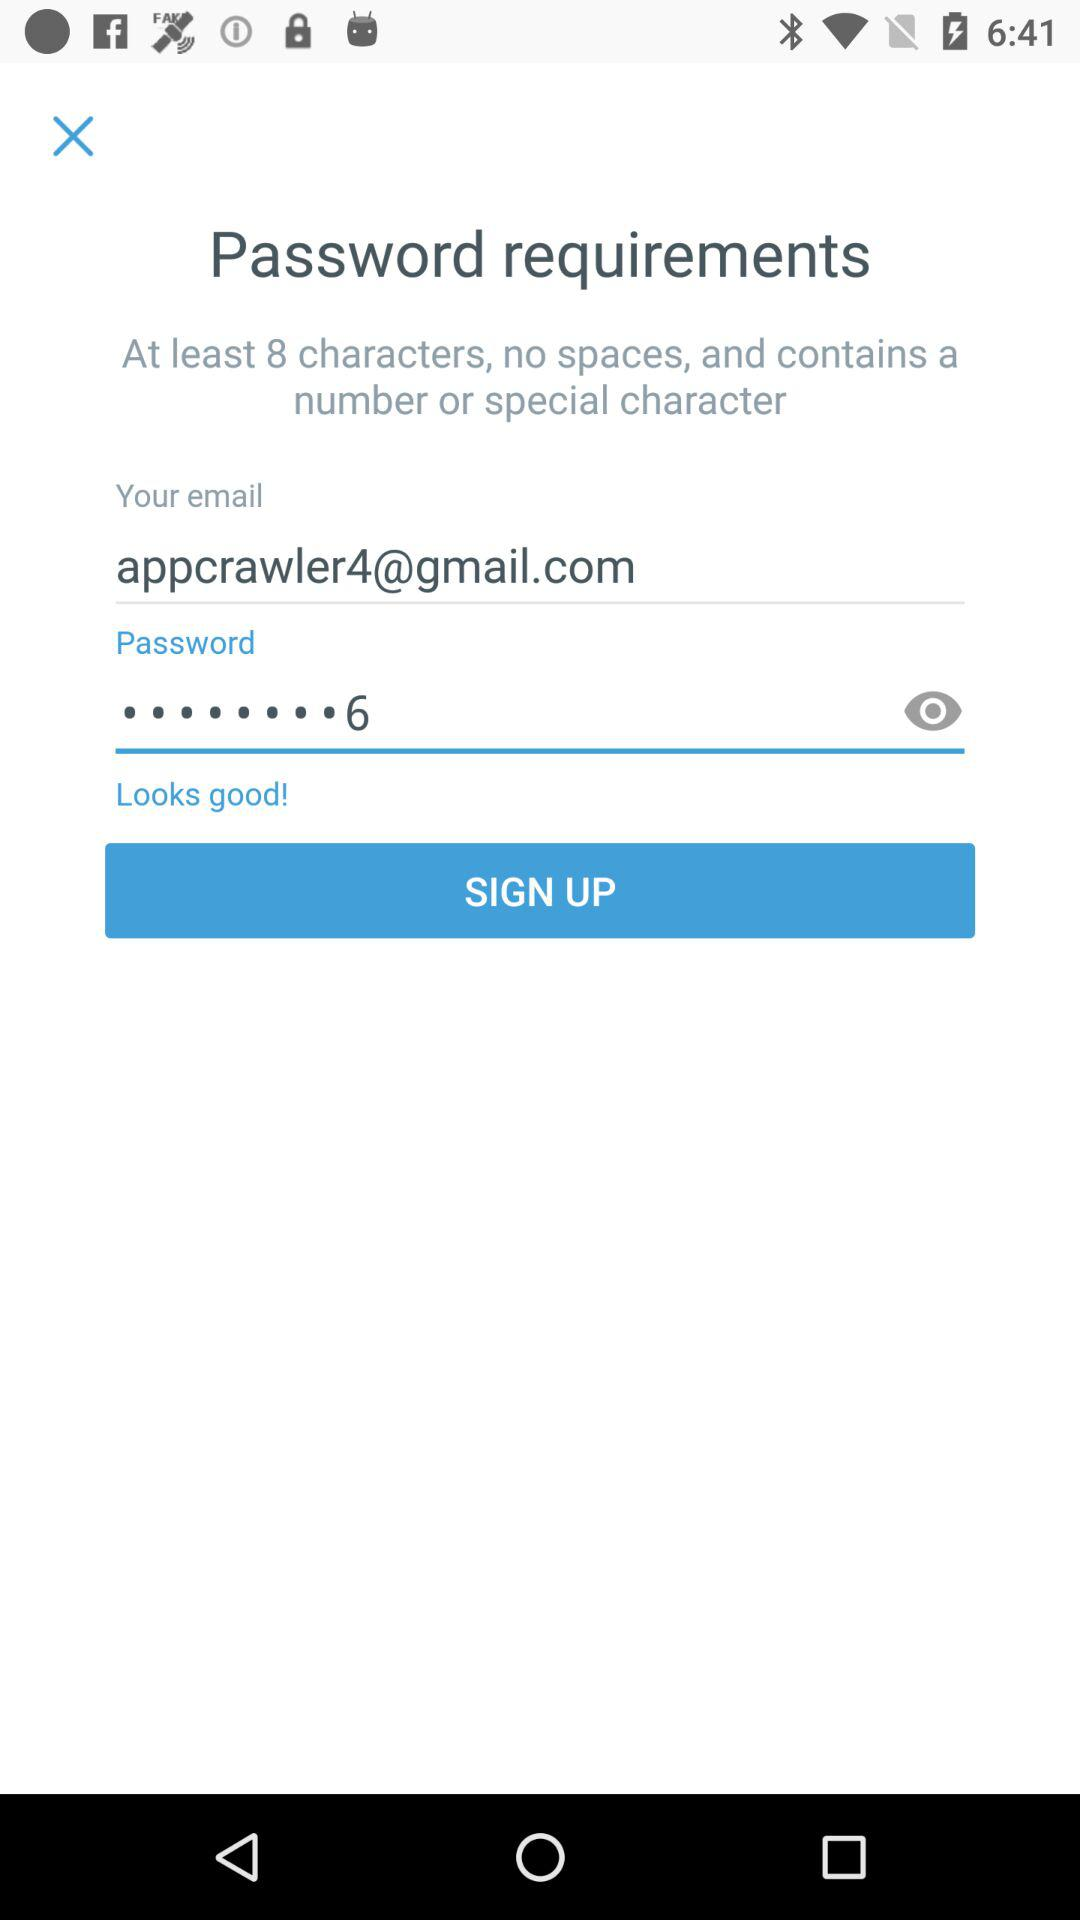What is the email address? The email address is appcrawler4@gmail.com. 